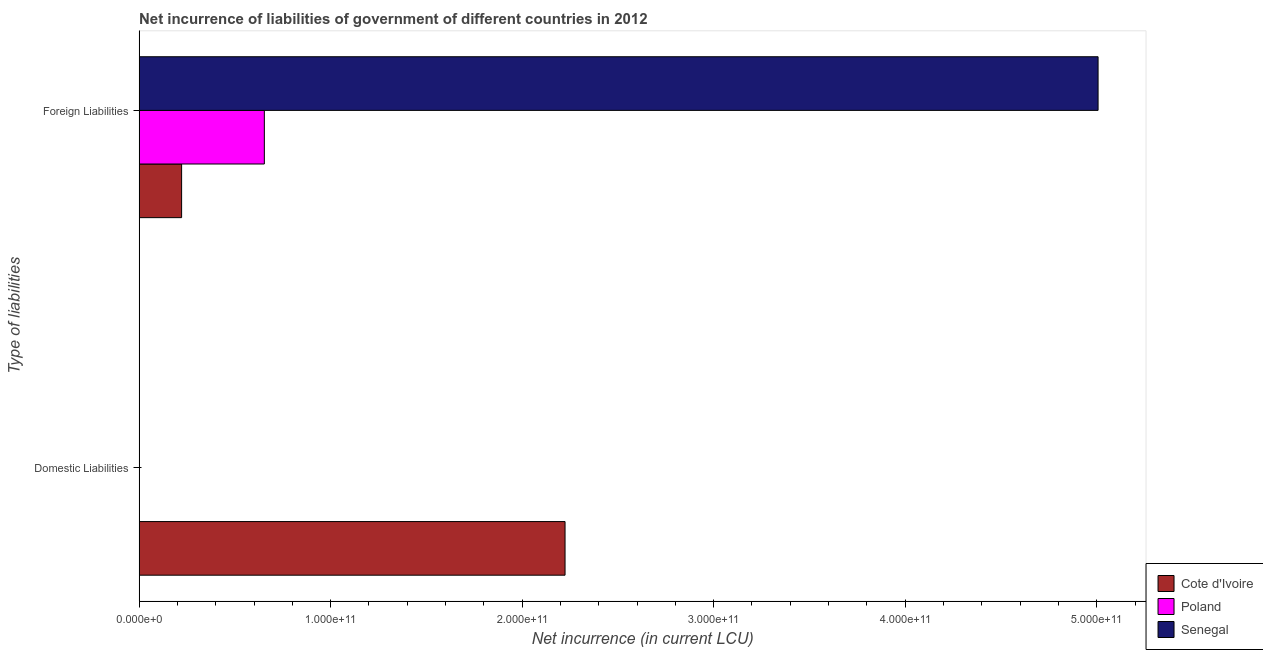How many bars are there on the 2nd tick from the top?
Provide a succinct answer. 1. What is the label of the 1st group of bars from the top?
Offer a very short reply. Foreign Liabilities. What is the net incurrence of foreign liabilities in Cote d'Ivoire?
Provide a short and direct response. 2.22e+1. Across all countries, what is the maximum net incurrence of domestic liabilities?
Give a very brief answer. 2.22e+11. Across all countries, what is the minimum net incurrence of foreign liabilities?
Offer a terse response. 2.22e+1. In which country was the net incurrence of foreign liabilities maximum?
Keep it short and to the point. Senegal. What is the total net incurrence of domestic liabilities in the graph?
Your response must be concise. 2.22e+11. What is the difference between the net incurrence of foreign liabilities in Poland and that in Cote d'Ivoire?
Keep it short and to the point. 4.32e+1. What is the difference between the net incurrence of domestic liabilities in Cote d'Ivoire and the net incurrence of foreign liabilities in Senegal?
Give a very brief answer. -2.78e+11. What is the average net incurrence of domestic liabilities per country?
Offer a very short reply. 7.41e+1. What is the difference between the net incurrence of domestic liabilities and net incurrence of foreign liabilities in Cote d'Ivoire?
Your answer should be compact. 2.00e+11. In how many countries, is the net incurrence of foreign liabilities greater than 380000000000 LCU?
Your answer should be compact. 1. What is the ratio of the net incurrence of foreign liabilities in Cote d'Ivoire to that in Senegal?
Give a very brief answer. 0.04. Are all the bars in the graph horizontal?
Give a very brief answer. Yes. How many countries are there in the graph?
Your answer should be very brief. 3. What is the difference between two consecutive major ticks on the X-axis?
Provide a succinct answer. 1.00e+11. Does the graph contain any zero values?
Make the answer very short. Yes. Does the graph contain grids?
Your answer should be very brief. No. Where does the legend appear in the graph?
Ensure brevity in your answer.  Bottom right. What is the title of the graph?
Provide a short and direct response. Net incurrence of liabilities of government of different countries in 2012. What is the label or title of the X-axis?
Offer a very short reply. Net incurrence (in current LCU). What is the label or title of the Y-axis?
Your answer should be compact. Type of liabilities. What is the Net incurrence (in current LCU) of Cote d'Ivoire in Domestic Liabilities?
Offer a terse response. 2.22e+11. What is the Net incurrence (in current LCU) in Cote d'Ivoire in Foreign Liabilities?
Provide a short and direct response. 2.22e+1. What is the Net incurrence (in current LCU) of Poland in Foreign Liabilities?
Offer a terse response. 6.54e+1. What is the Net incurrence (in current LCU) of Senegal in Foreign Liabilities?
Offer a very short reply. 5.01e+11. Across all Type of liabilities, what is the maximum Net incurrence (in current LCU) of Cote d'Ivoire?
Provide a succinct answer. 2.22e+11. Across all Type of liabilities, what is the maximum Net incurrence (in current LCU) in Poland?
Make the answer very short. 6.54e+1. Across all Type of liabilities, what is the maximum Net incurrence (in current LCU) in Senegal?
Make the answer very short. 5.01e+11. Across all Type of liabilities, what is the minimum Net incurrence (in current LCU) of Cote d'Ivoire?
Your answer should be compact. 2.22e+1. What is the total Net incurrence (in current LCU) of Cote d'Ivoire in the graph?
Your answer should be compact. 2.45e+11. What is the total Net incurrence (in current LCU) of Poland in the graph?
Keep it short and to the point. 6.54e+1. What is the total Net incurrence (in current LCU) of Senegal in the graph?
Provide a short and direct response. 5.01e+11. What is the difference between the Net incurrence (in current LCU) of Cote d'Ivoire in Domestic Liabilities and that in Foreign Liabilities?
Ensure brevity in your answer.  2.00e+11. What is the difference between the Net incurrence (in current LCU) of Cote d'Ivoire in Domestic Liabilities and the Net incurrence (in current LCU) of Poland in Foreign Liabilities?
Keep it short and to the point. 1.57e+11. What is the difference between the Net incurrence (in current LCU) of Cote d'Ivoire in Domestic Liabilities and the Net incurrence (in current LCU) of Senegal in Foreign Liabilities?
Keep it short and to the point. -2.78e+11. What is the average Net incurrence (in current LCU) of Cote d'Ivoire per Type of liabilities?
Keep it short and to the point. 1.22e+11. What is the average Net incurrence (in current LCU) of Poland per Type of liabilities?
Your answer should be very brief. 3.27e+1. What is the average Net incurrence (in current LCU) of Senegal per Type of liabilities?
Offer a terse response. 2.50e+11. What is the difference between the Net incurrence (in current LCU) in Cote d'Ivoire and Net incurrence (in current LCU) in Poland in Foreign Liabilities?
Keep it short and to the point. -4.32e+1. What is the difference between the Net incurrence (in current LCU) in Cote d'Ivoire and Net incurrence (in current LCU) in Senegal in Foreign Liabilities?
Provide a succinct answer. -4.79e+11. What is the difference between the Net incurrence (in current LCU) in Poland and Net incurrence (in current LCU) in Senegal in Foreign Liabilities?
Your answer should be very brief. -4.35e+11. What is the ratio of the Net incurrence (in current LCU) of Cote d'Ivoire in Domestic Liabilities to that in Foreign Liabilities?
Ensure brevity in your answer.  10.02. What is the difference between the highest and the second highest Net incurrence (in current LCU) in Cote d'Ivoire?
Your response must be concise. 2.00e+11. What is the difference between the highest and the lowest Net incurrence (in current LCU) in Cote d'Ivoire?
Offer a very short reply. 2.00e+11. What is the difference between the highest and the lowest Net incurrence (in current LCU) in Poland?
Keep it short and to the point. 6.54e+1. What is the difference between the highest and the lowest Net incurrence (in current LCU) in Senegal?
Offer a very short reply. 5.01e+11. 